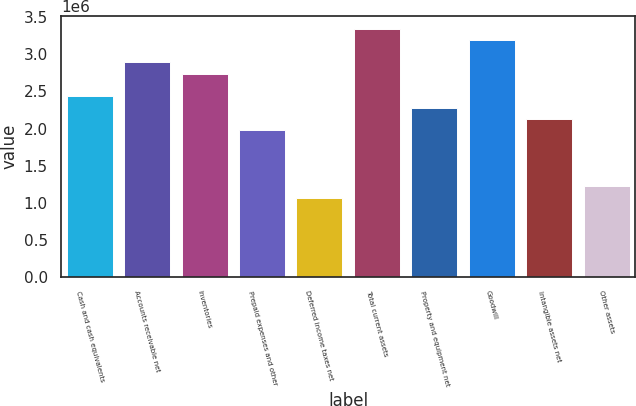<chart> <loc_0><loc_0><loc_500><loc_500><bar_chart><fcel>Cash and cash equivalents<fcel>Accounts receivable net<fcel>Inventories<fcel>Prepaid expenses and other<fcel>Deferred income taxes net<fcel>Total current assets<fcel>Property and equipment net<fcel>Goodwill<fcel>Intangible assets net<fcel>Other assets<nl><fcel>2.43509e+06<fcel>2.89135e+06<fcel>2.73926e+06<fcel>1.97882e+06<fcel>1.06628e+06<fcel>3.34762e+06<fcel>2.283e+06<fcel>3.19553e+06<fcel>2.13091e+06<fcel>1.21837e+06<nl></chart> 